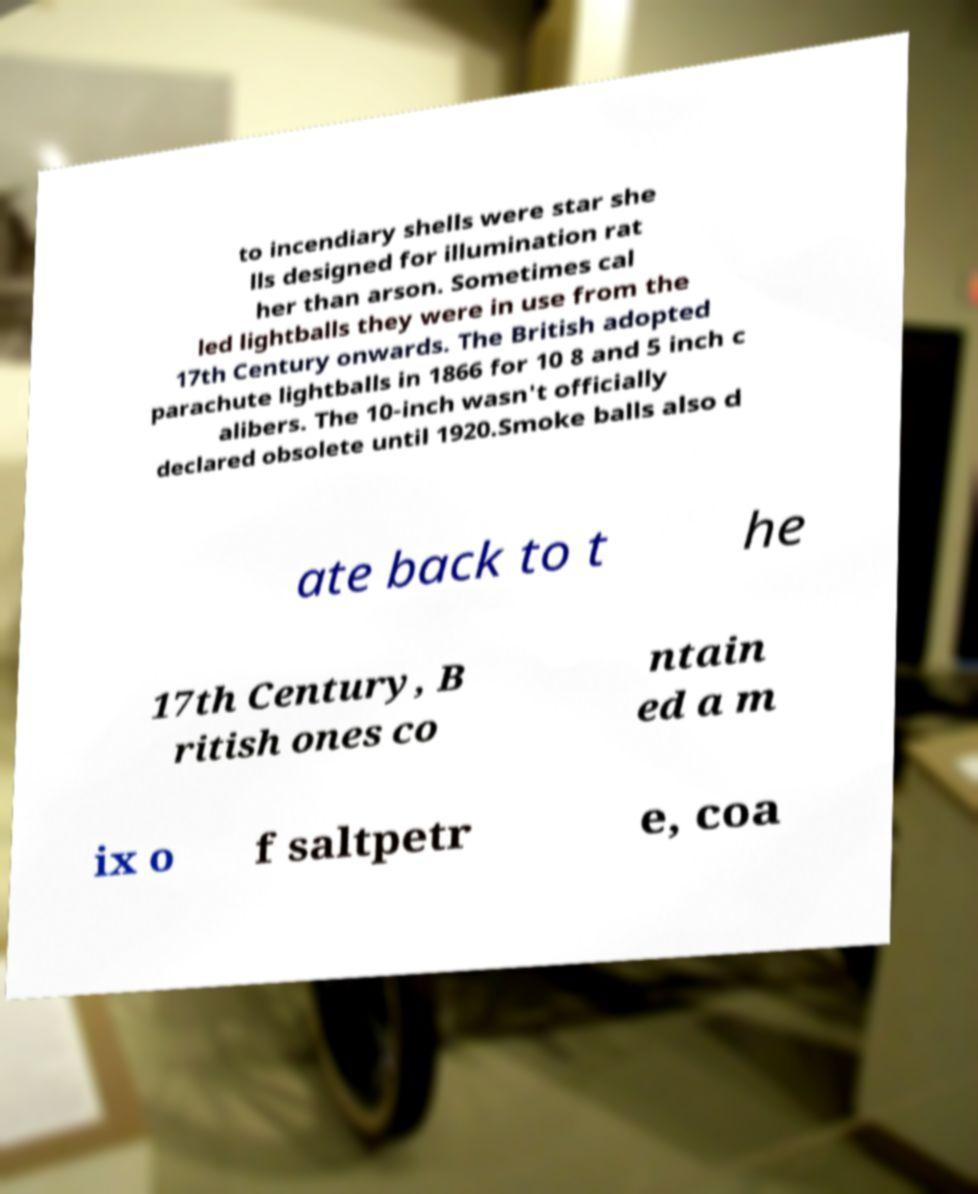What messages or text are displayed in this image? I need them in a readable, typed format. to incendiary shells were star she lls designed for illumination rat her than arson. Sometimes cal led lightballs they were in use from the 17th Century onwards. The British adopted parachute lightballs in 1866 for 10 8 and 5 inch c alibers. The 10-inch wasn't officially declared obsolete until 1920.Smoke balls also d ate back to t he 17th Century, B ritish ones co ntain ed a m ix o f saltpetr e, coa 